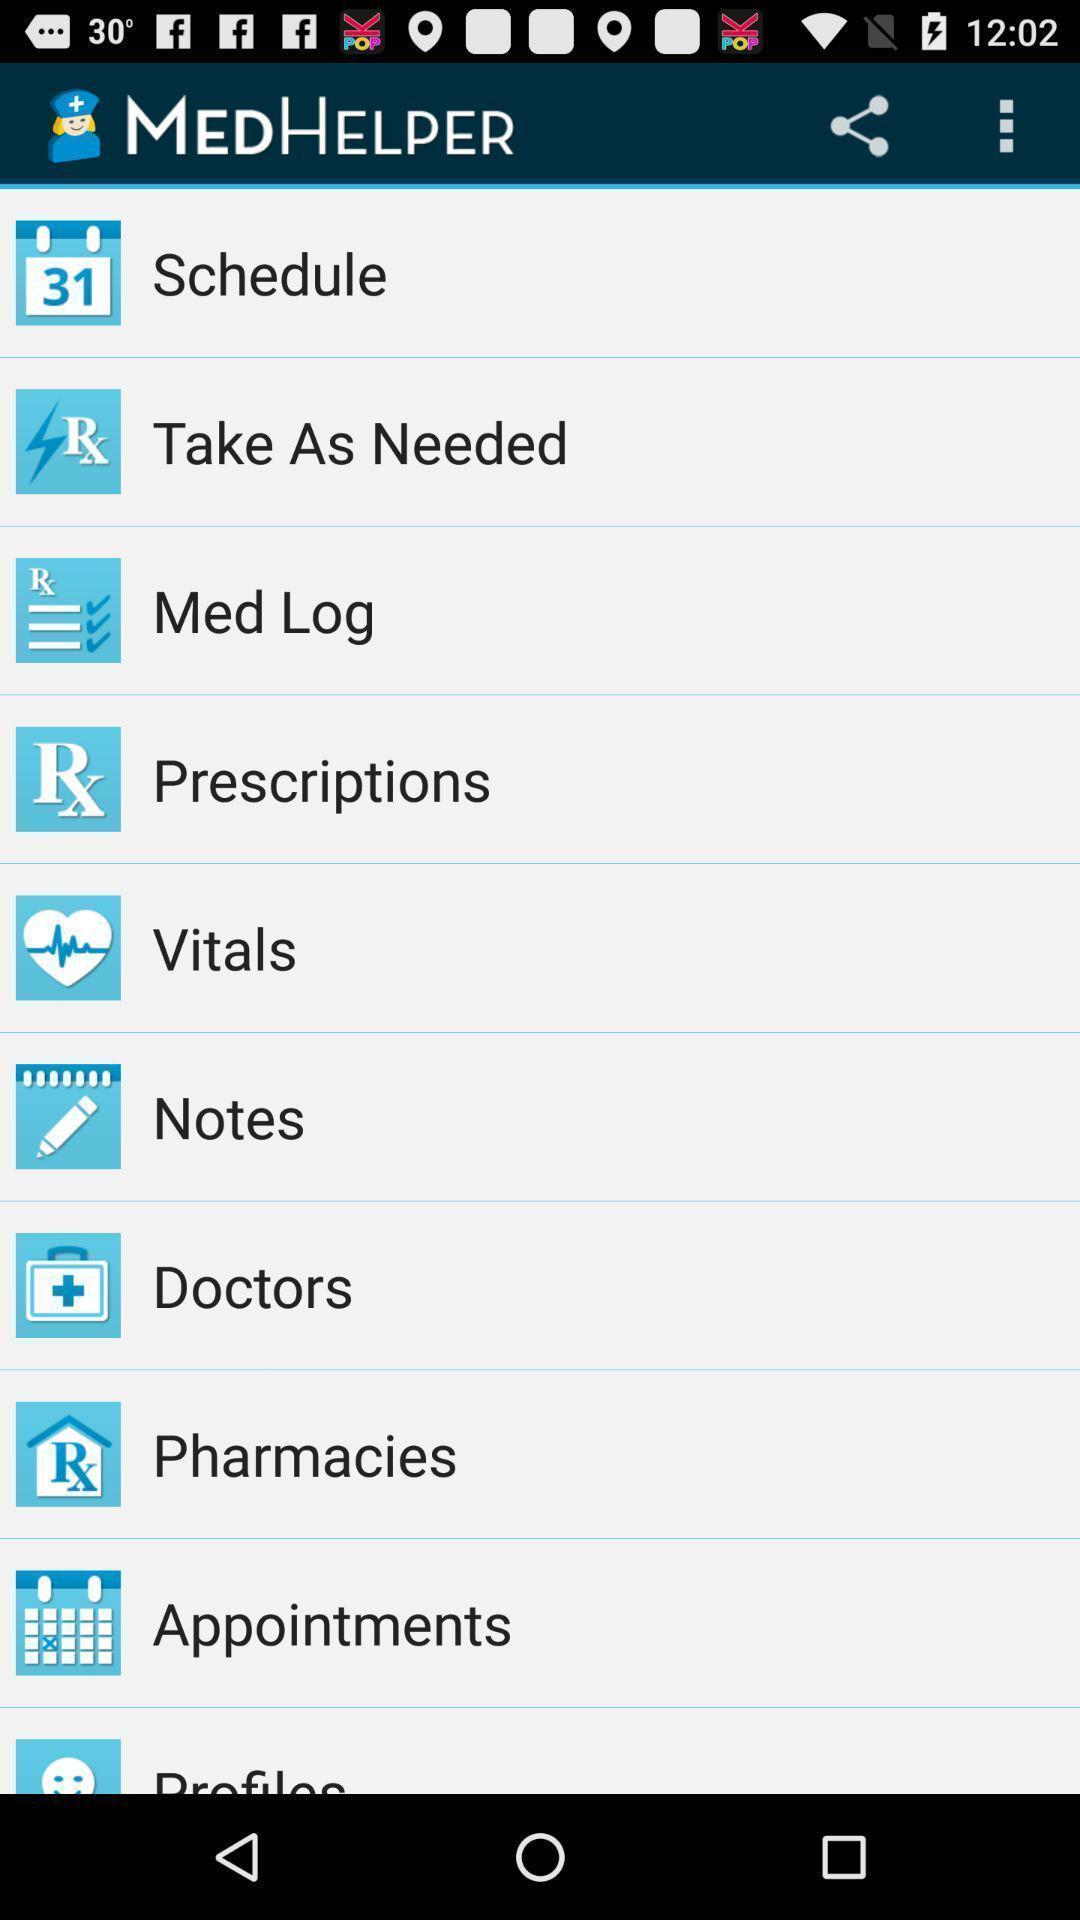Describe the content in this image. Page displaying list of options in health application. 